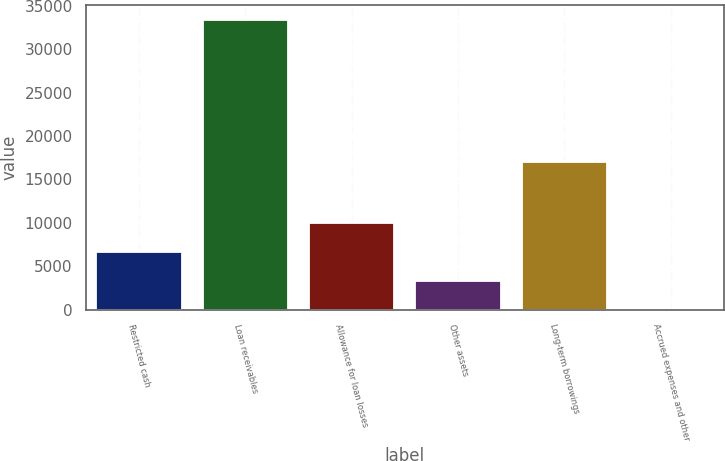Convert chart. <chart><loc_0><loc_0><loc_500><loc_500><bar_chart><fcel>Restricted cash<fcel>Loan receivables<fcel>Allowance for loan losses<fcel>Other assets<fcel>Long-term borrowings<fcel>Accrued expenses and other<nl><fcel>6679.2<fcel>33360<fcel>10014.3<fcel>3344.1<fcel>16986<fcel>9<nl></chart> 